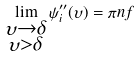Convert formula to latex. <formula><loc_0><loc_0><loc_500><loc_500>\lim _ { \substack { \upsilon \to \delta \\ \upsilon > \delta } } \psi _ { i } ^ { \prime \prime } ( \upsilon ) = \pi n f</formula> 